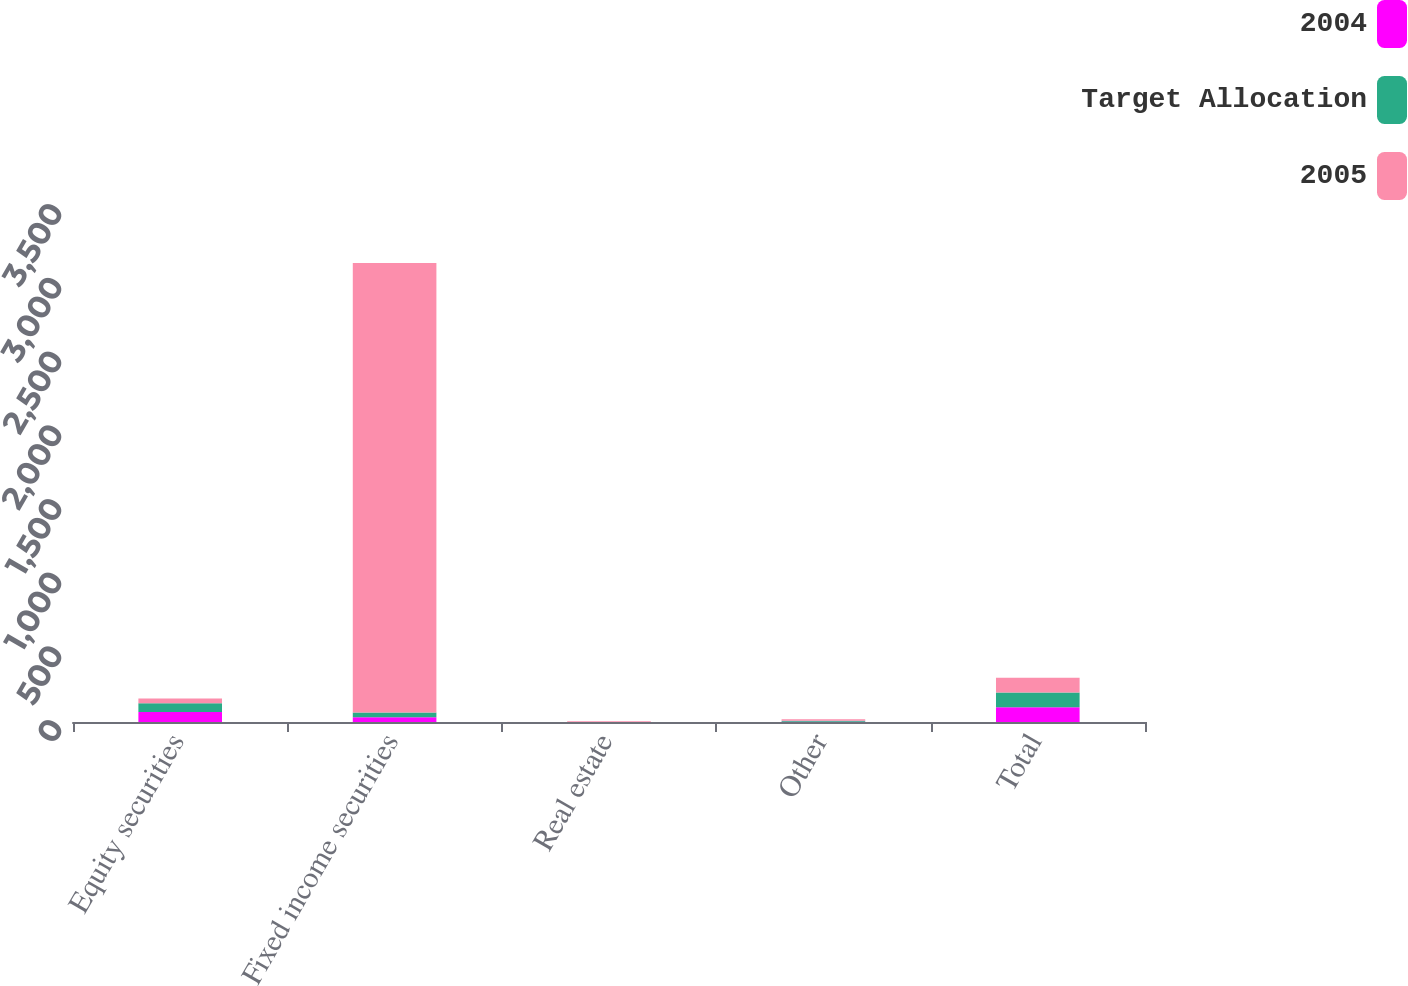<chart> <loc_0><loc_0><loc_500><loc_500><stacked_bar_chart><ecel><fcel>Equity securities<fcel>Fixed income securities<fcel>Real estate<fcel>Other<fcel>Total<nl><fcel>2004<fcel>67<fcel>32<fcel>0<fcel>1<fcel>100<nl><fcel>Target Allocation<fcel>60<fcel>32<fcel>0<fcel>8<fcel>100<nl><fcel>2005<fcel>32<fcel>3050<fcel>5<fcel>10<fcel>100<nl></chart> 